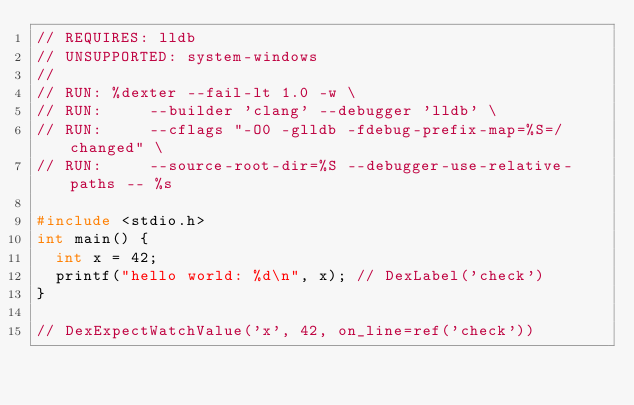<code> <loc_0><loc_0><loc_500><loc_500><_C++_>// REQUIRES: lldb
// UNSUPPORTED: system-windows
//
// RUN: %dexter --fail-lt 1.0 -w \
// RUN:     --builder 'clang' --debugger 'lldb' \
// RUN:     --cflags "-O0 -glldb -fdebug-prefix-map=%S=/changed" \
// RUN:     --source-root-dir=%S --debugger-use-relative-paths -- %s

#include <stdio.h>
int main() {
  int x = 42;
  printf("hello world: %d\n", x); // DexLabel('check')
}

// DexExpectWatchValue('x', 42, on_line=ref('check'))
</code> 